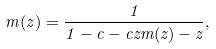Convert formula to latex. <formula><loc_0><loc_0><loc_500><loc_500>m ( z ) = \frac { 1 } { 1 - c - c z m ( z ) - z } ,</formula> 